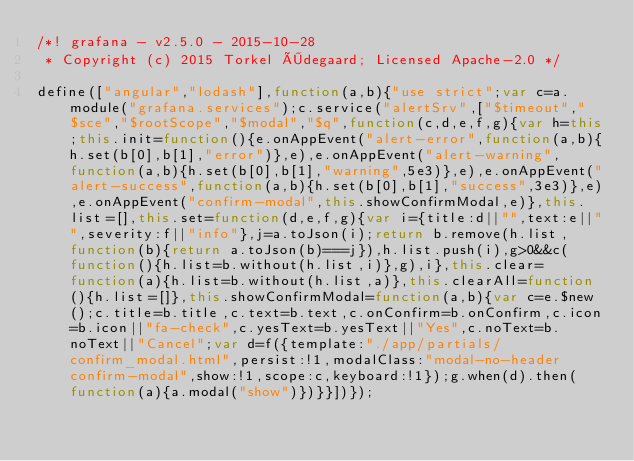Convert code to text. <code><loc_0><loc_0><loc_500><loc_500><_JavaScript_>/*! grafana - v2.5.0 - 2015-10-28
 * Copyright (c) 2015 Torkel Ödegaard; Licensed Apache-2.0 */

define(["angular","lodash"],function(a,b){"use strict";var c=a.module("grafana.services");c.service("alertSrv",["$timeout","$sce","$rootScope","$modal","$q",function(c,d,e,f,g){var h=this;this.init=function(){e.onAppEvent("alert-error",function(a,b){h.set(b[0],b[1],"error")},e),e.onAppEvent("alert-warning",function(a,b){h.set(b[0],b[1],"warning",5e3)},e),e.onAppEvent("alert-success",function(a,b){h.set(b[0],b[1],"success",3e3)},e),e.onAppEvent("confirm-modal",this.showConfirmModal,e)},this.list=[],this.set=function(d,e,f,g){var i={title:d||"",text:e||"",severity:f||"info"},j=a.toJson(i);return b.remove(h.list,function(b){return a.toJson(b)===j}),h.list.push(i),g>0&&c(function(){h.list=b.without(h.list,i)},g),i},this.clear=function(a){h.list=b.without(h.list,a)},this.clearAll=function(){h.list=[]},this.showConfirmModal=function(a,b){var c=e.$new();c.title=b.title,c.text=b.text,c.onConfirm=b.onConfirm,c.icon=b.icon||"fa-check",c.yesText=b.yesText||"Yes",c.noText=b.noText||"Cancel";var d=f({template:"./app/partials/confirm_modal.html",persist:!1,modalClass:"modal-no-header confirm-modal",show:!1,scope:c,keyboard:!1});g.when(d).then(function(a){a.modal("show")})}}])});</code> 